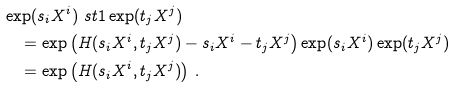<formula> <loc_0><loc_0><loc_500><loc_500>& \exp ( s _ { i } X ^ { i } ) \ s t { 1 } \exp ( t _ { j } X ^ { j } ) \\ & \quad = \exp \left ( H ( s _ { i } X ^ { i } , t _ { j } X ^ { j } ) - s _ { i } X ^ { i } - t _ { j } X ^ { j } \right ) \exp ( s _ { i } X ^ { i } ) \exp ( t _ { j } X ^ { j } ) \\ & \quad = \exp \left ( H ( s _ { i } X ^ { i } , t _ { j } X ^ { j } ) \right ) \, .</formula> 